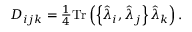<formula> <loc_0><loc_0><loc_500><loc_500>\begin{array} { r } { D _ { i j k } = \frac { 1 } { 4 } T r \left ( \left \{ \hat { \lambda } _ { i } , \hat { \lambda } _ { j } \right \} \hat { \lambda } _ { k } \right ) . } \end{array}</formula> 